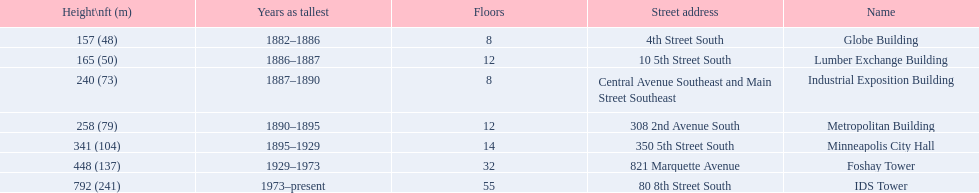What are all the building names? Globe Building, Lumber Exchange Building, Industrial Exposition Building, Metropolitan Building, Minneapolis City Hall, Foshay Tower, IDS Tower. And their heights? 157 (48), 165 (50), 240 (73), 258 (79), 341 (104), 448 (137), 792 (241). Between metropolitan building and lumber exchange building, which is taller? Metropolitan Building. 